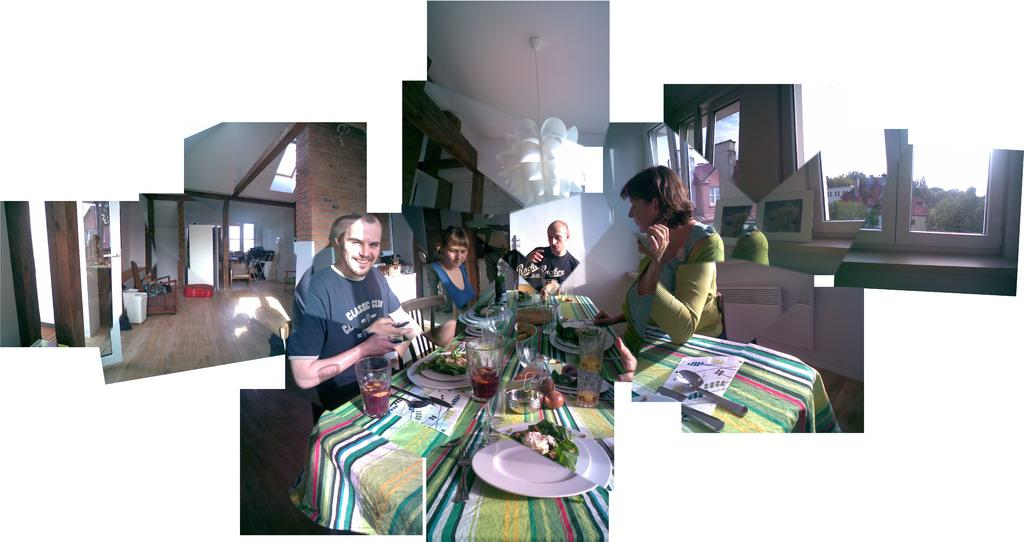What is present in the image that serves as a backdrop or barrier? There is a wall in the image. What are the people in the image doing? The people in the image are sitting. What piece of furniture can be seen in the image? There is a table in the image. What items are on the table? There is a plate, a bowl, and a glass on the table. Can you tell me how many masks are hanging on the wall in the image? There are no masks present in the image; it only features a wall, people sitting, a table, and items on the table. What type of harbor can be seen in the image? There is no harbor present in the image; it is an indoor scene with a wall, people sitting, a table, and items on the table. 